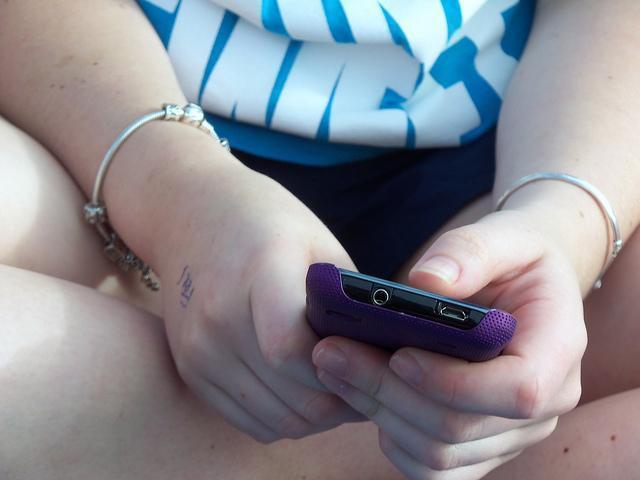How many bracelets do you see?
Give a very brief answer. 2. How many buses are here?
Give a very brief answer. 0. 